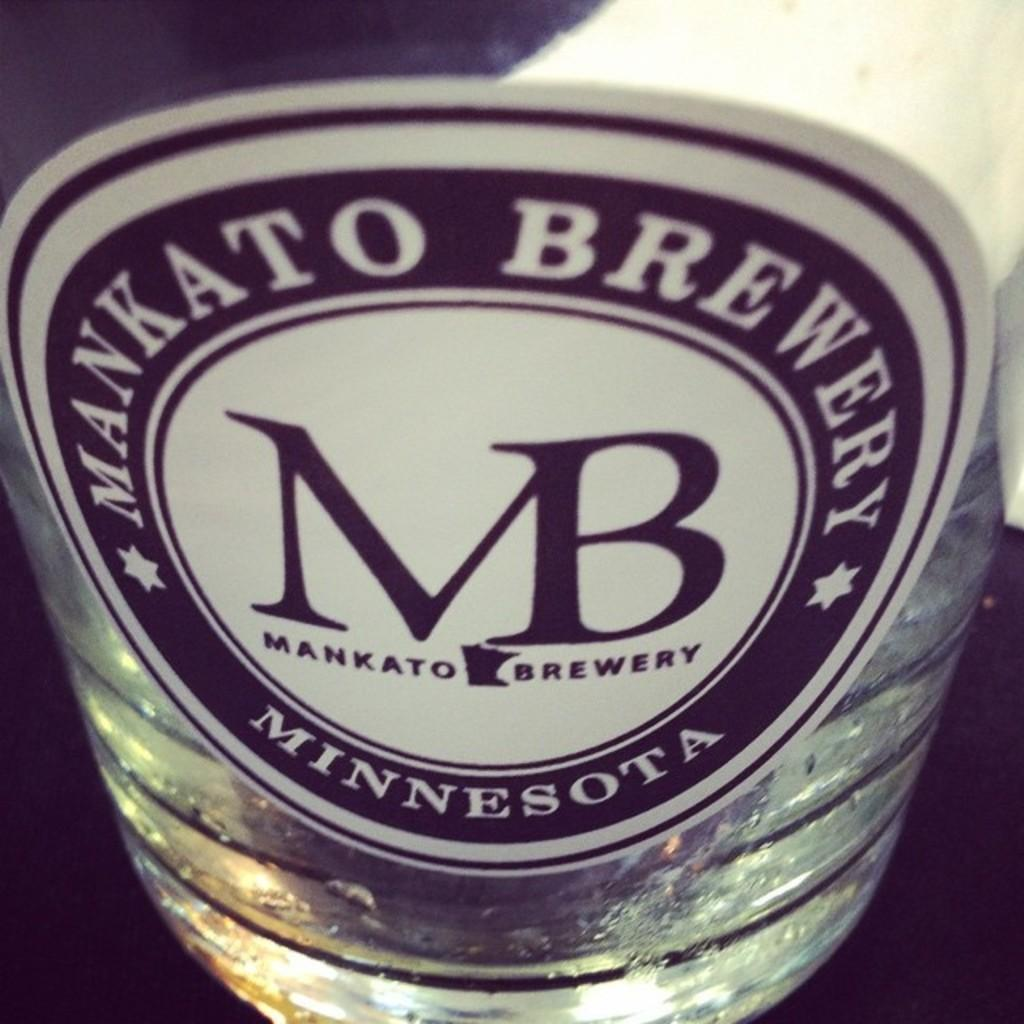<image>
Give a short and clear explanation of the subsequent image. The beer bottle is from Mankato Brewery Minnesota. 